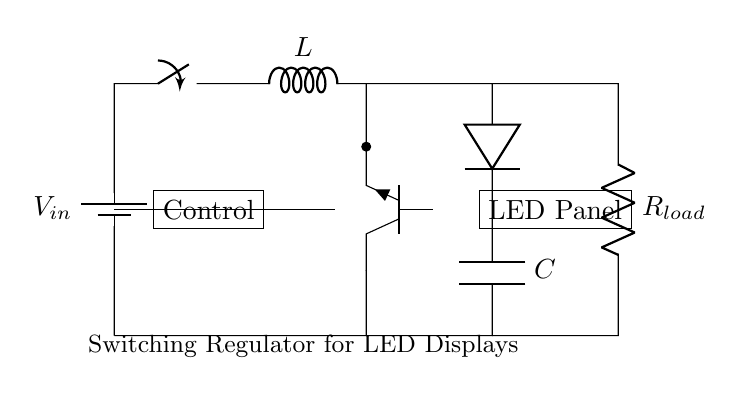What is the input voltage designated as in the circuit? The input voltage is labeled as \( V_{in} \), which is shown next to the battery symbol at the top left of the diagram.
Answer: V_{in} What components are involved in converting high-voltage to low-voltage? The main components responsible for voltage conversion are the inductor labeled \( L \), the diode, and the capacitor labeled \( C \). These components work together in the switching regulator configuration.
Answer: L, diode, C What type of transistor is used in this circuit? The circuit uses an NPN transistor, which is indicated by the label \( npn \) next to the transistor symbol in the schematic.
Answer: NPN How does the load connect to the switch output? The load, represented as \( R_{load} \), connects from the switch output directly to the ground. This is shown by a wire leading from the output of the switch to the loader and back down to the common ground point.
Answer: Directly What is the role of the diode in this circuit? The diode allows current to flow in one direction only, preventing any reverse current that might damage the circuit components, especially the LED panel connected as a load.
Answer: Prevents reverse current Which component is responsible for energy storage during operation? The inductor labeled \( L \) is responsible for storing energy during operation, collecting energy when the switch is closed and releasing it when the switch is open.
Answer: L What would happen if the capacitor \( C \) were removed from the circuit? If the capacitor \( C \) were removed, the circuit would become less stable, possibly causing voltage fluctuations at the load due to insufficient filtering of the output from the switching regulator.
Answer: Voltage fluctuations 